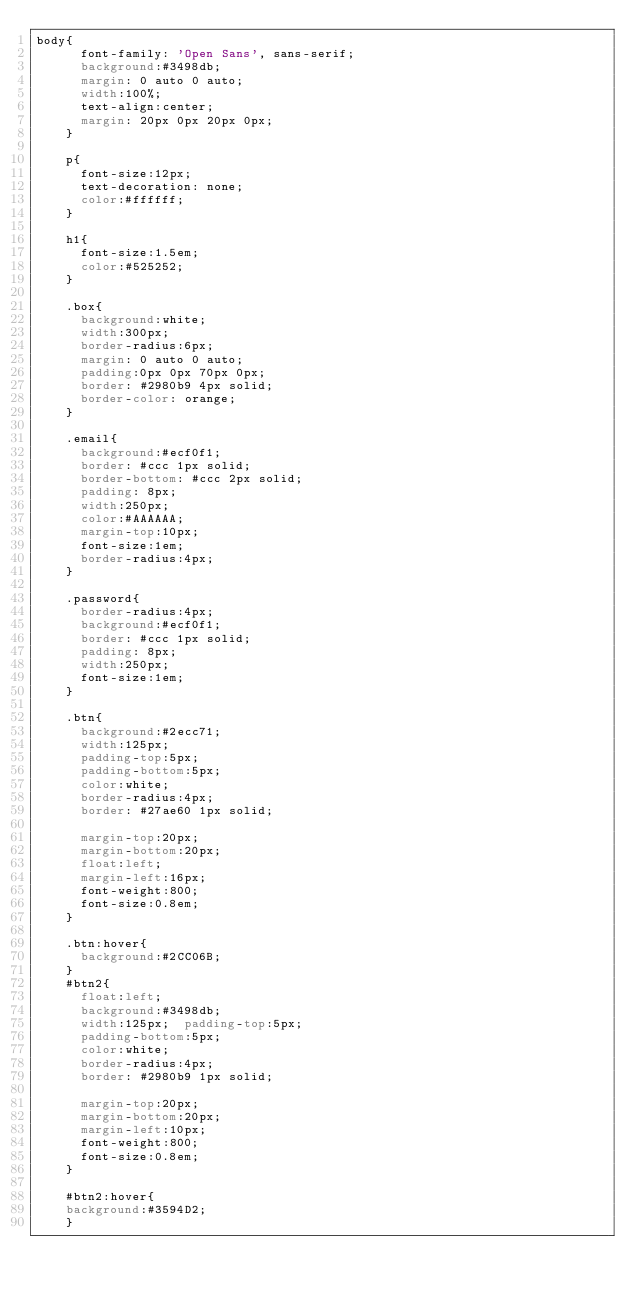Convert code to text. <code><loc_0><loc_0><loc_500><loc_500><_CSS_>body{
      font-family: 'Open Sans', sans-serif;
      background:#3498db;
      margin: 0 auto 0 auto;
      width:100%;
      text-align:center;
      margin: 20px 0px 20px 0px;
    }

    p{
      font-size:12px;
      text-decoration: none;
      color:#ffffff;
    }

    h1{
      font-size:1.5em;
      color:#525252;
    }

    .box{
      background:white;
      width:300px;
      border-radius:6px;
      margin: 0 auto 0 auto;
      padding:0px 0px 70px 0px;
      border: #2980b9 4px solid;
      border-color: orange;
    }

    .email{
      background:#ecf0f1;
      border: #ccc 1px solid;
      border-bottom: #ccc 2px solid;
      padding: 8px;
      width:250px;
      color:#AAAAAA;
      margin-top:10px;
      font-size:1em;
      border-radius:4px;
    }

    .password{
      border-radius:4px;
      background:#ecf0f1;
      border: #ccc 1px solid;
      padding: 8px;
      width:250px;
      font-size:1em;
    }

    .btn{
      background:#2ecc71;
      width:125px;
      padding-top:5px;
      padding-bottom:5px;
      color:white;
      border-radius:4px;
      border: #27ae60 1px solid;

      margin-top:20px;
      margin-bottom:20px;
      float:left;
      margin-left:16px;
      font-weight:800;
      font-size:0.8em;
    }

    .btn:hover{
      background:#2CC06B;
    }
    #btn2{
      float:left;
      background:#3498db;
      width:125px;  padding-top:5px;
      padding-bottom:5px;
      color:white;
      border-radius:4px;
      border: #2980b9 1px solid;

      margin-top:20px;
      margin-bottom:20px;
      margin-left:10px;
      font-weight:800;
      font-size:0.8em;
    }

    #btn2:hover{
    background:#3594D2;
    }
</code> 